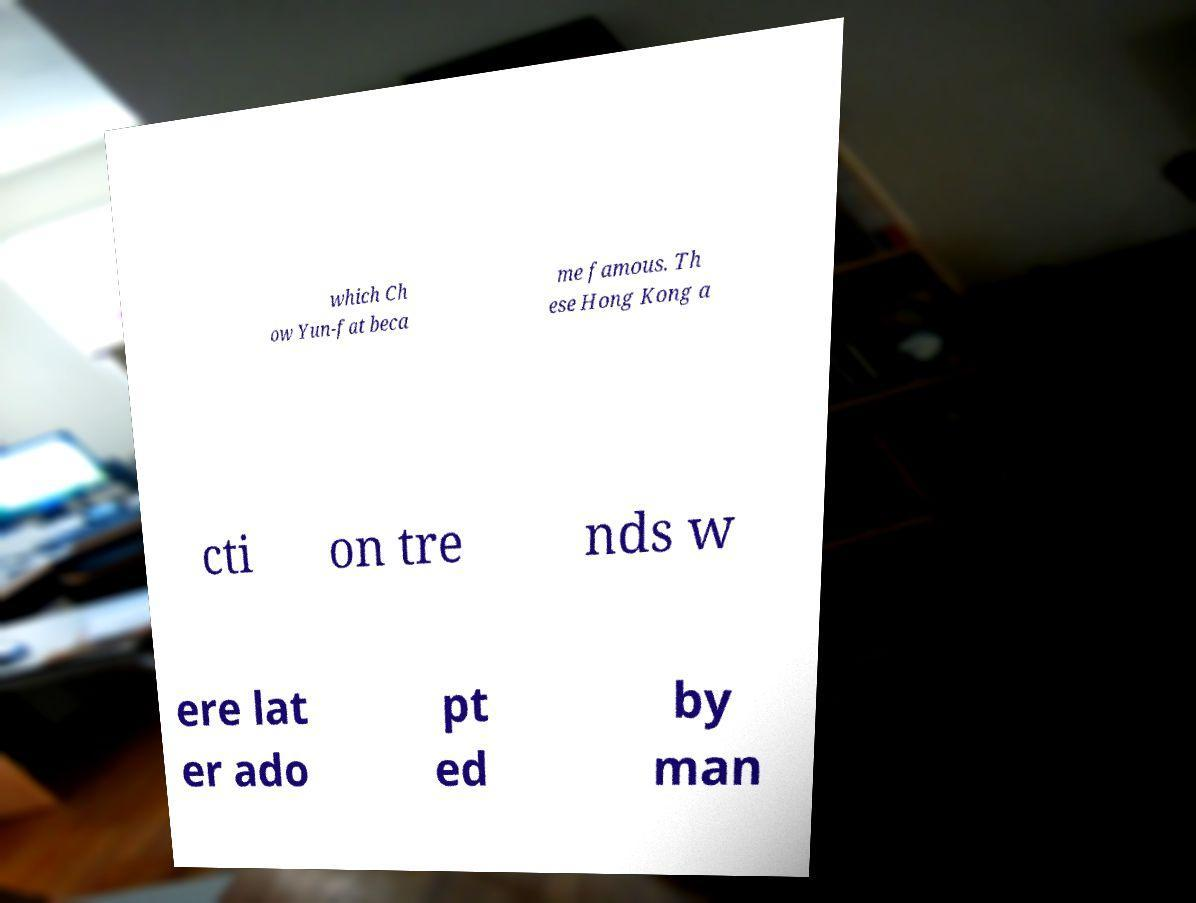Can you read and provide the text displayed in the image?This photo seems to have some interesting text. Can you extract and type it out for me? which Ch ow Yun-fat beca me famous. Th ese Hong Kong a cti on tre nds w ere lat er ado pt ed by man 